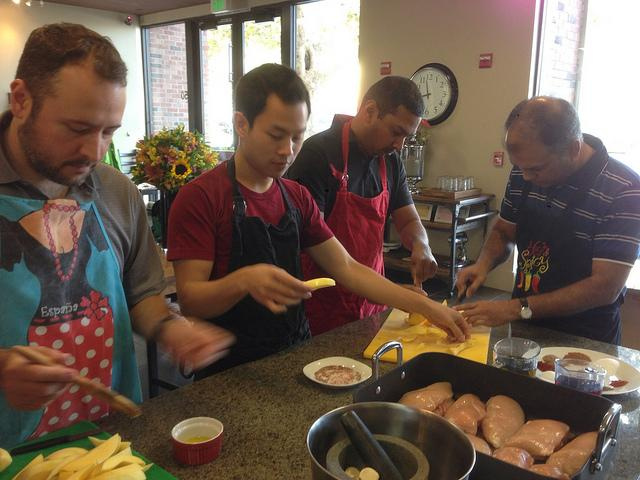What do these people do here? cook 